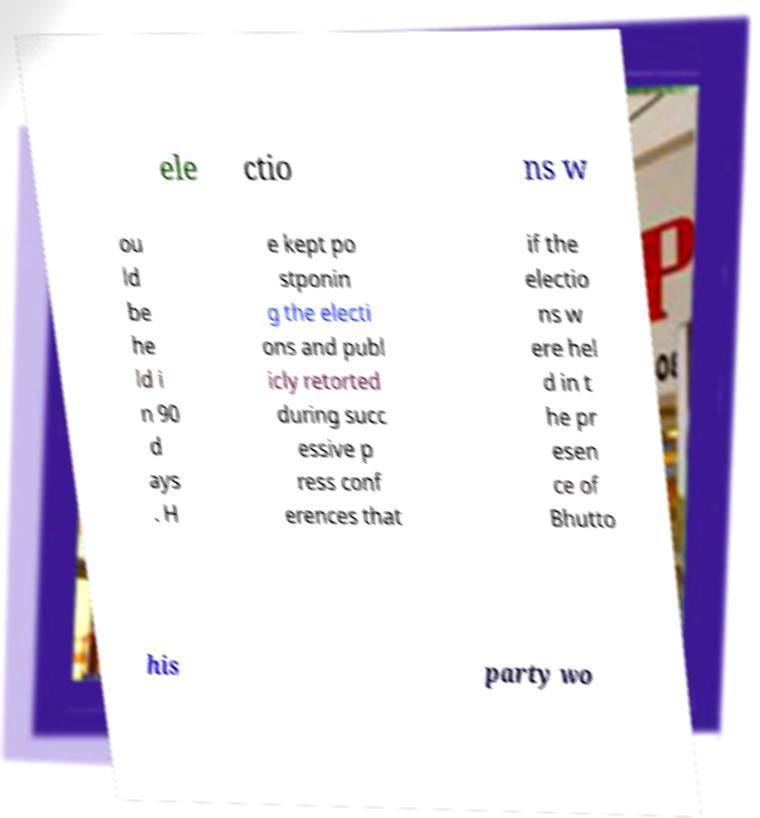Please read and relay the text visible in this image. What does it say? ele ctio ns w ou ld be he ld i n 90 d ays . H e kept po stponin g the electi ons and publ icly retorted during succ essive p ress conf erences that if the electio ns w ere hel d in t he pr esen ce of Bhutto his party wo 